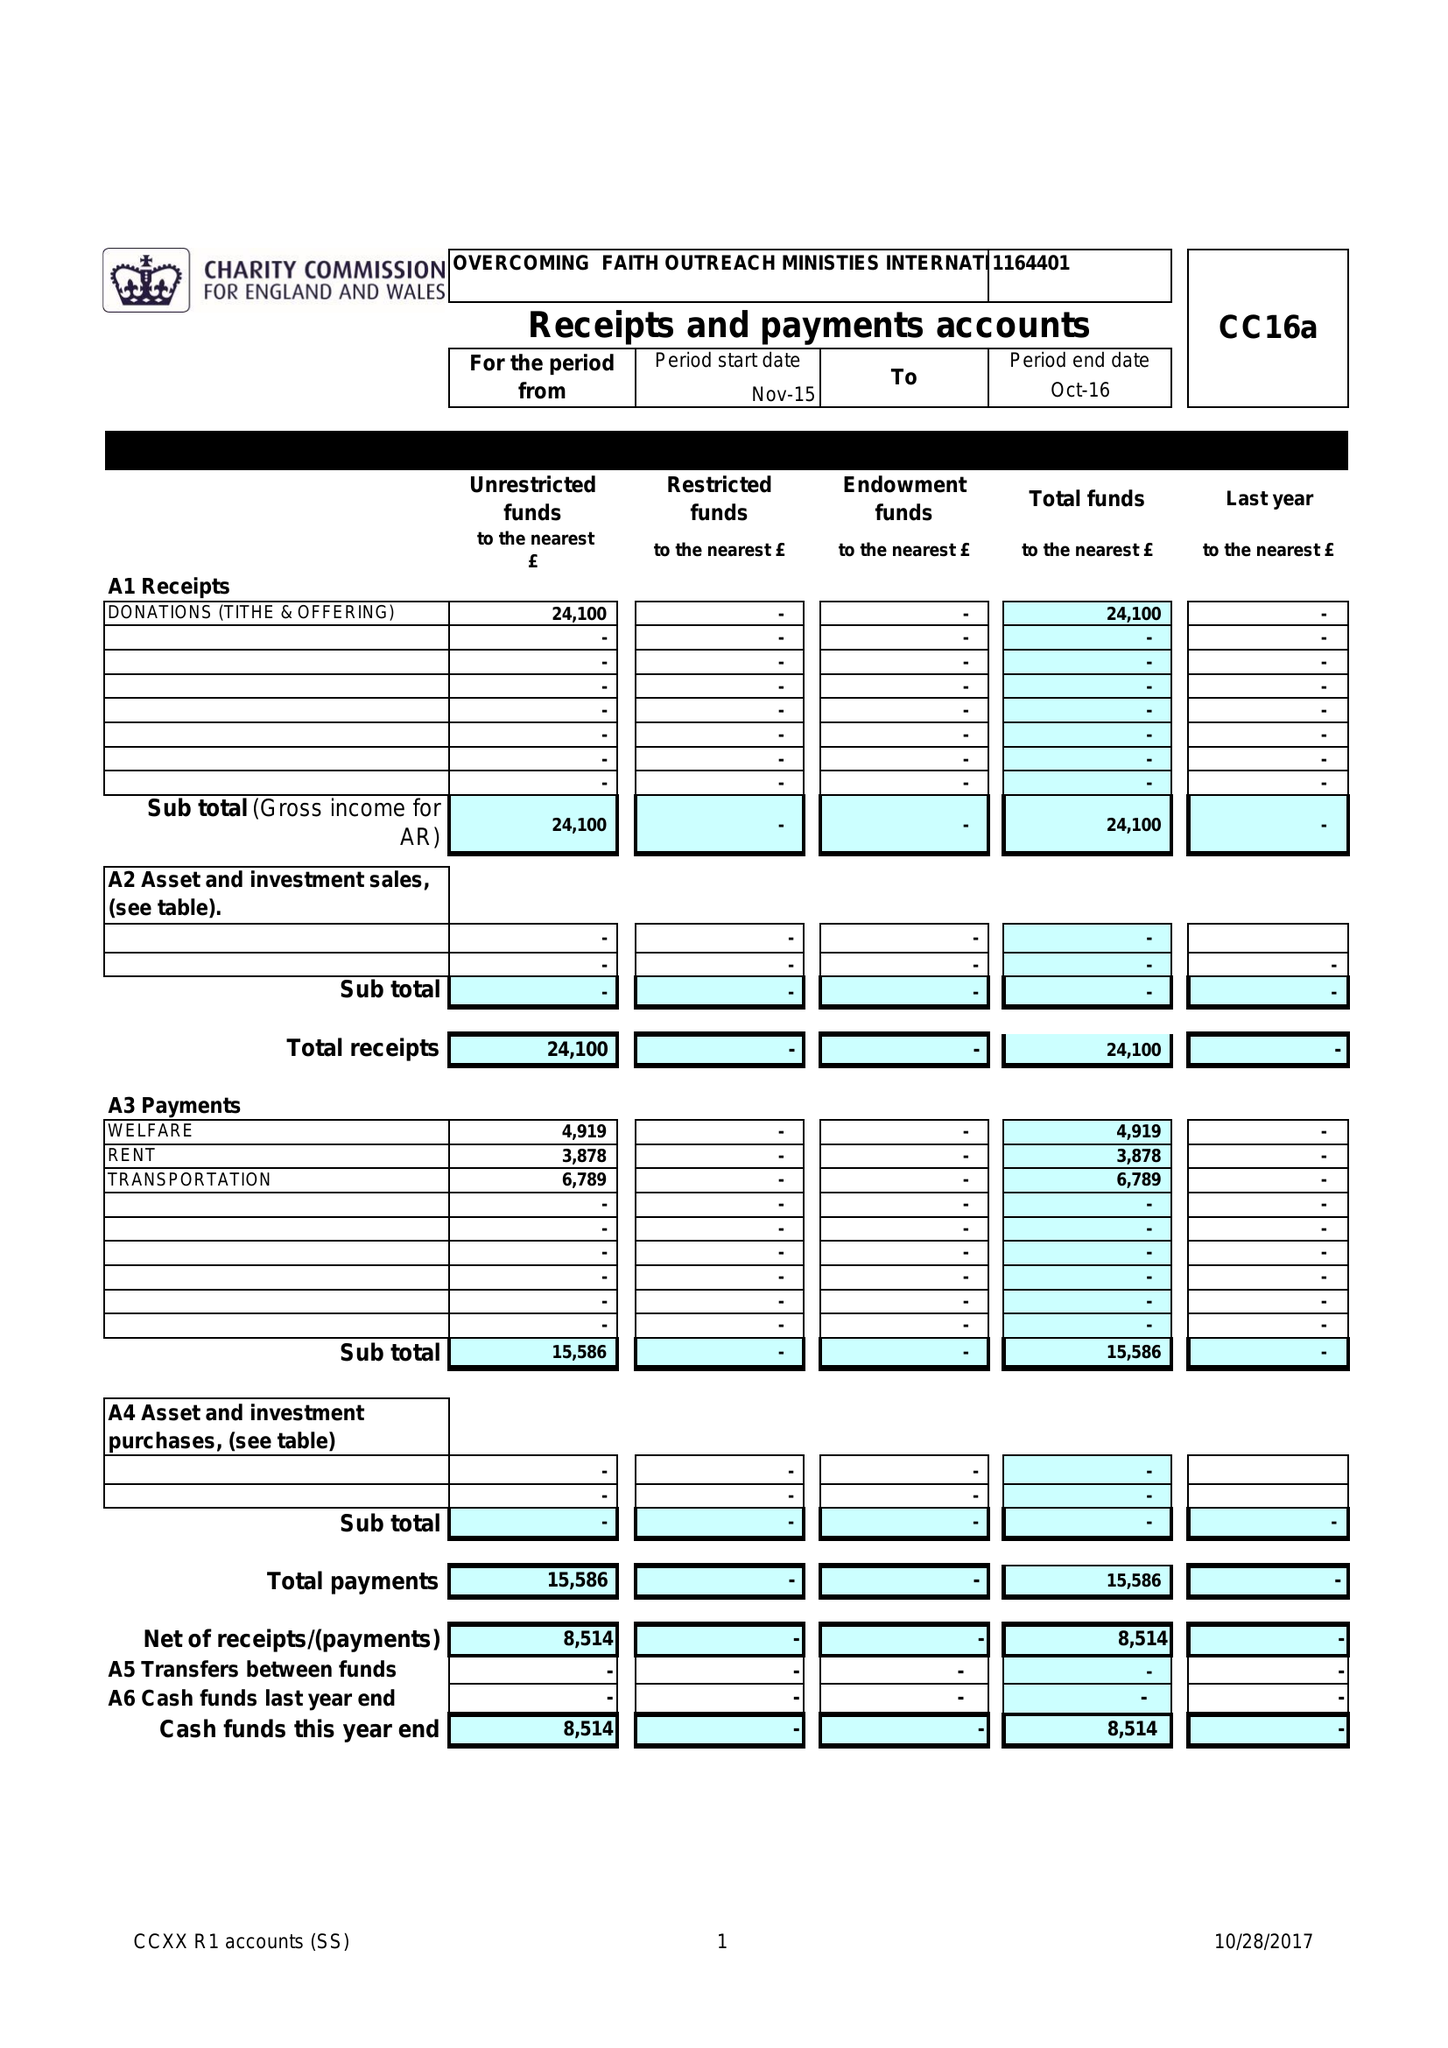What is the value for the charity_name?
Answer the question using a single word or phrase. Overcoming Faith Outreach Ministries International 